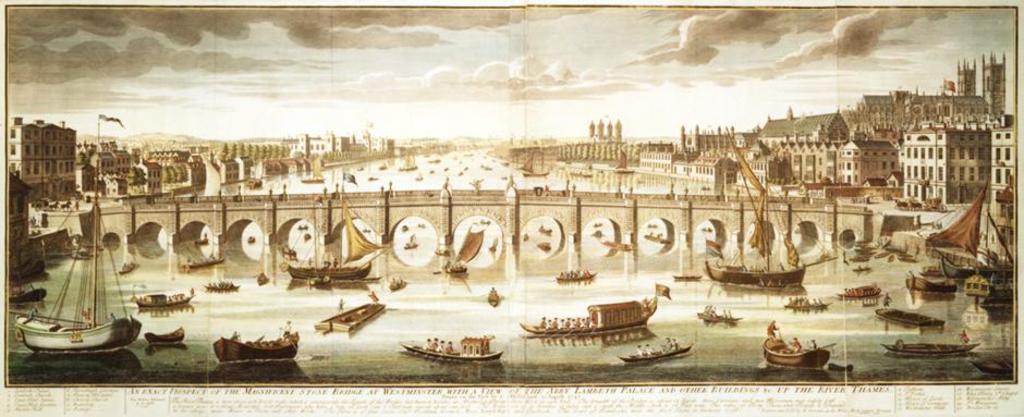Can you describe this image briefly? This image consists of a newspaper with many images and a text on it. At the top of the image there is the sky with clouds. At the bottom of the image there is a river with water. On the left and right sides of the image there are many buildings and houses. In the middle of the image there is a bridge and there are many boats on the river. There are a few flags. 